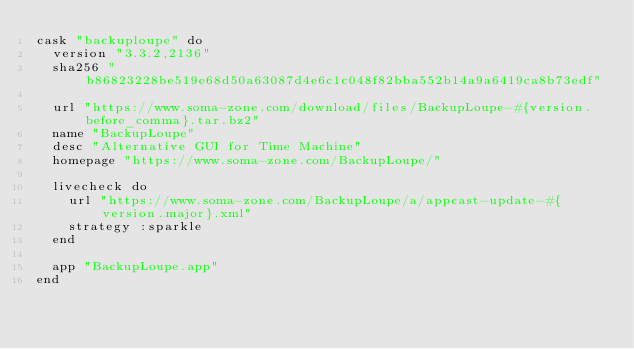<code> <loc_0><loc_0><loc_500><loc_500><_Ruby_>cask "backuploupe" do
  version "3.3.2,2136"
  sha256 "b86823228be519e68d50a63087d4e6c1c048f82bba552b14a9a6419ca8b73edf"

  url "https://www.soma-zone.com/download/files/BackupLoupe-#{version.before_comma}.tar.bz2"
  name "BackupLoupe"
  desc "Alternative GUI for Time Machine"
  homepage "https://www.soma-zone.com/BackupLoupe/"

  livecheck do
    url "https://www.soma-zone.com/BackupLoupe/a/appcast-update-#{version.major}.xml"
    strategy :sparkle
  end

  app "BackupLoupe.app"
end
</code> 